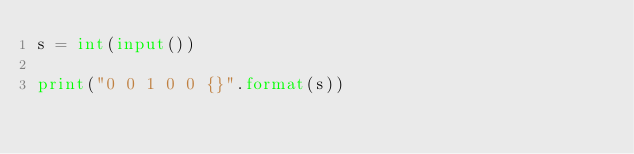<code> <loc_0><loc_0><loc_500><loc_500><_Python_>s = int(input())

print("0 0 1 0 0 {}".format(s))
</code> 